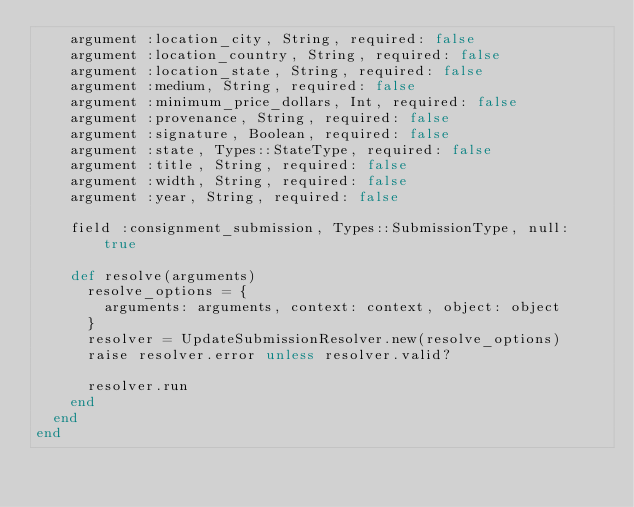<code> <loc_0><loc_0><loc_500><loc_500><_Ruby_>    argument :location_city, String, required: false
    argument :location_country, String, required: false
    argument :location_state, String, required: false
    argument :medium, String, required: false
    argument :minimum_price_dollars, Int, required: false
    argument :provenance, String, required: false
    argument :signature, Boolean, required: false
    argument :state, Types::StateType, required: false
    argument :title, String, required: false
    argument :width, String, required: false
    argument :year, String, required: false

    field :consignment_submission, Types::SubmissionType, null: true

    def resolve(arguments)
      resolve_options = {
        arguments: arguments, context: context, object: object
      }
      resolver = UpdateSubmissionResolver.new(resolve_options)
      raise resolver.error unless resolver.valid?

      resolver.run
    end
  end
end
</code> 